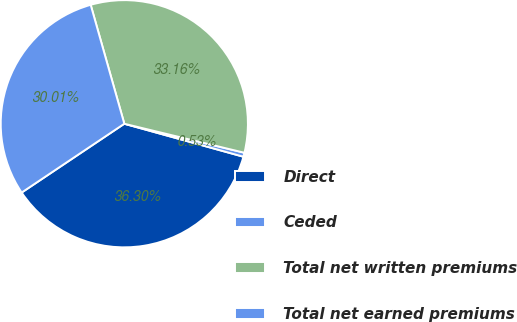Convert chart to OTSL. <chart><loc_0><loc_0><loc_500><loc_500><pie_chart><fcel>Direct<fcel>Ceded<fcel>Total net written premiums<fcel>Total net earned premiums<nl><fcel>36.3%<fcel>0.53%<fcel>33.16%<fcel>30.01%<nl></chart> 